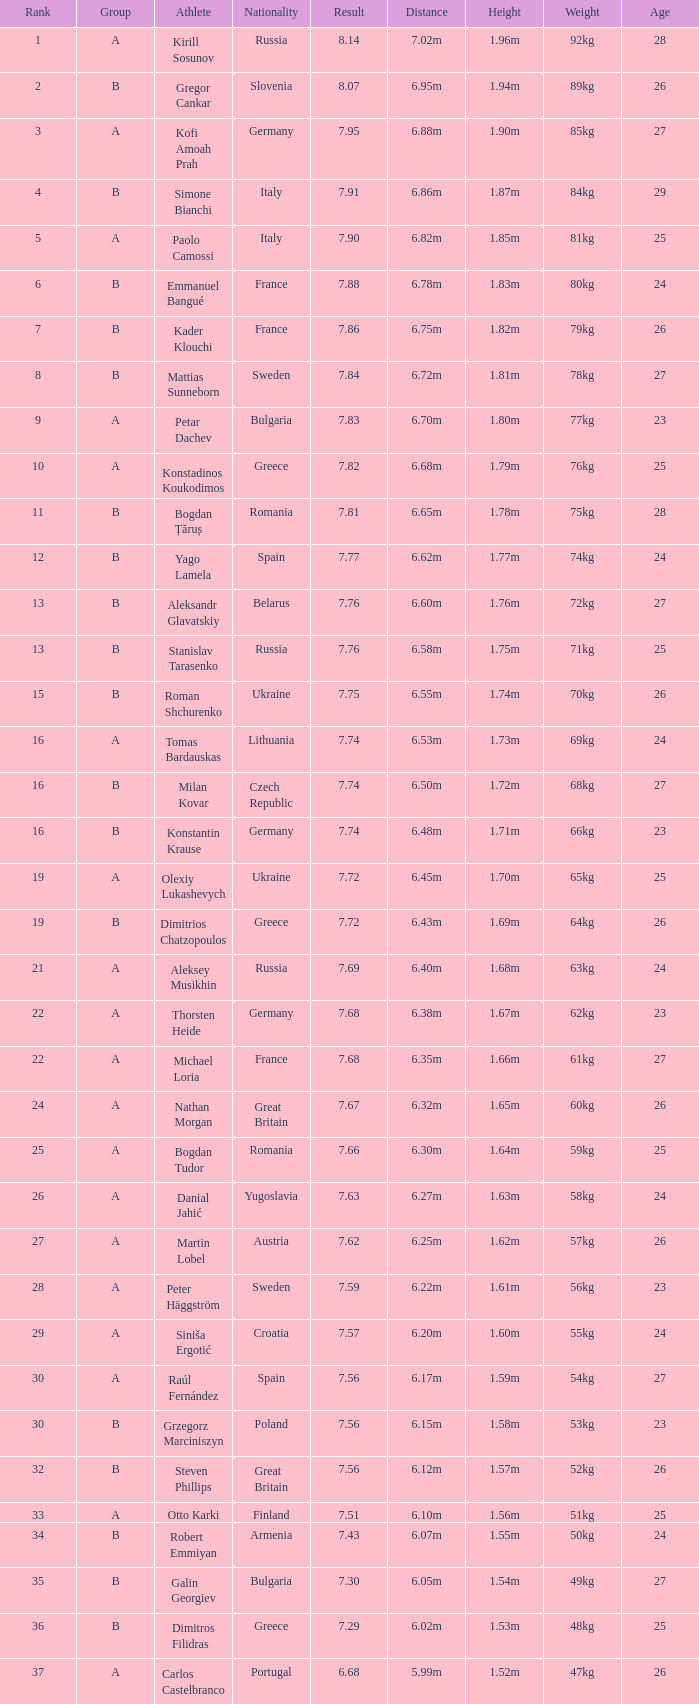Which athlete's rank is more than 15 when the result is less than 7.68, the group is b, and the nationality listed is Great Britain? Steven Phillips. 